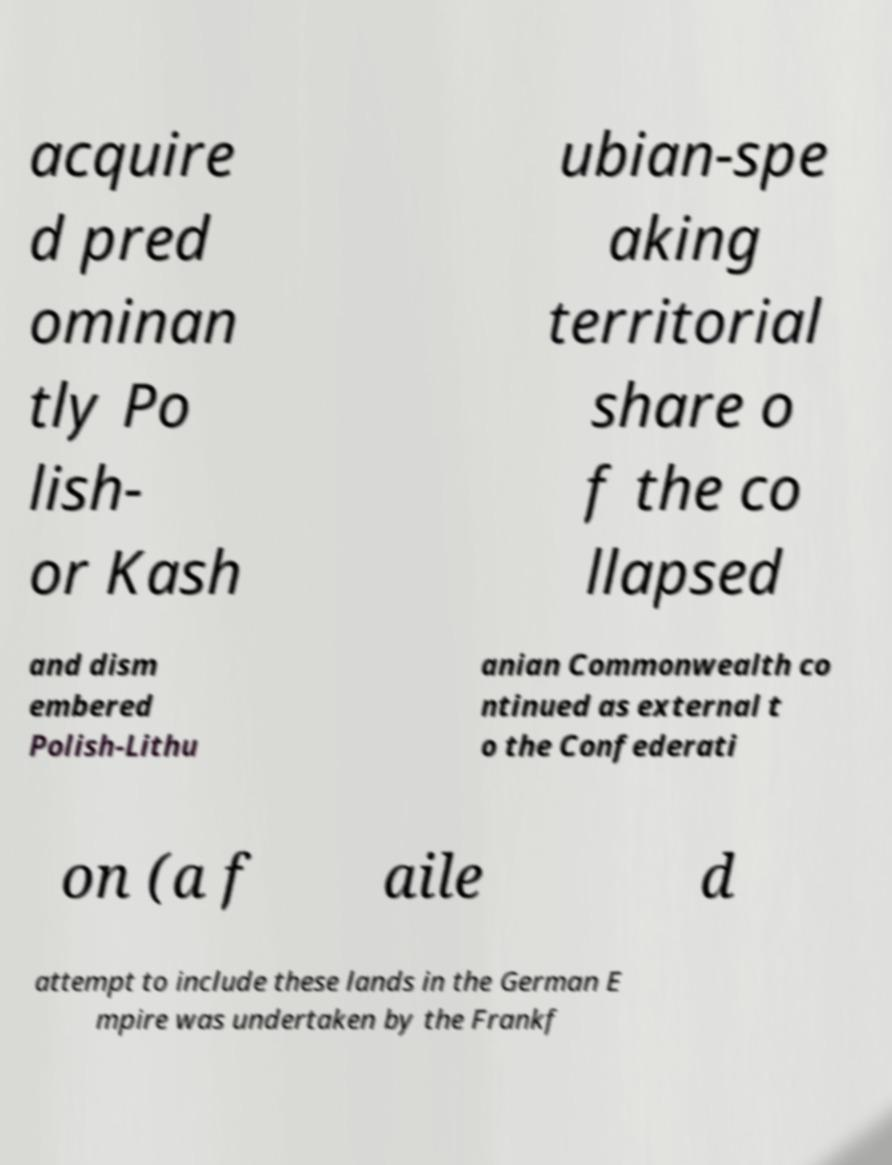For documentation purposes, I need the text within this image transcribed. Could you provide that? acquire d pred ominan tly Po lish- or Kash ubian-spe aking territorial share o f the co llapsed and dism embered Polish-Lithu anian Commonwealth co ntinued as external t o the Confederati on (a f aile d attempt to include these lands in the German E mpire was undertaken by the Frankf 